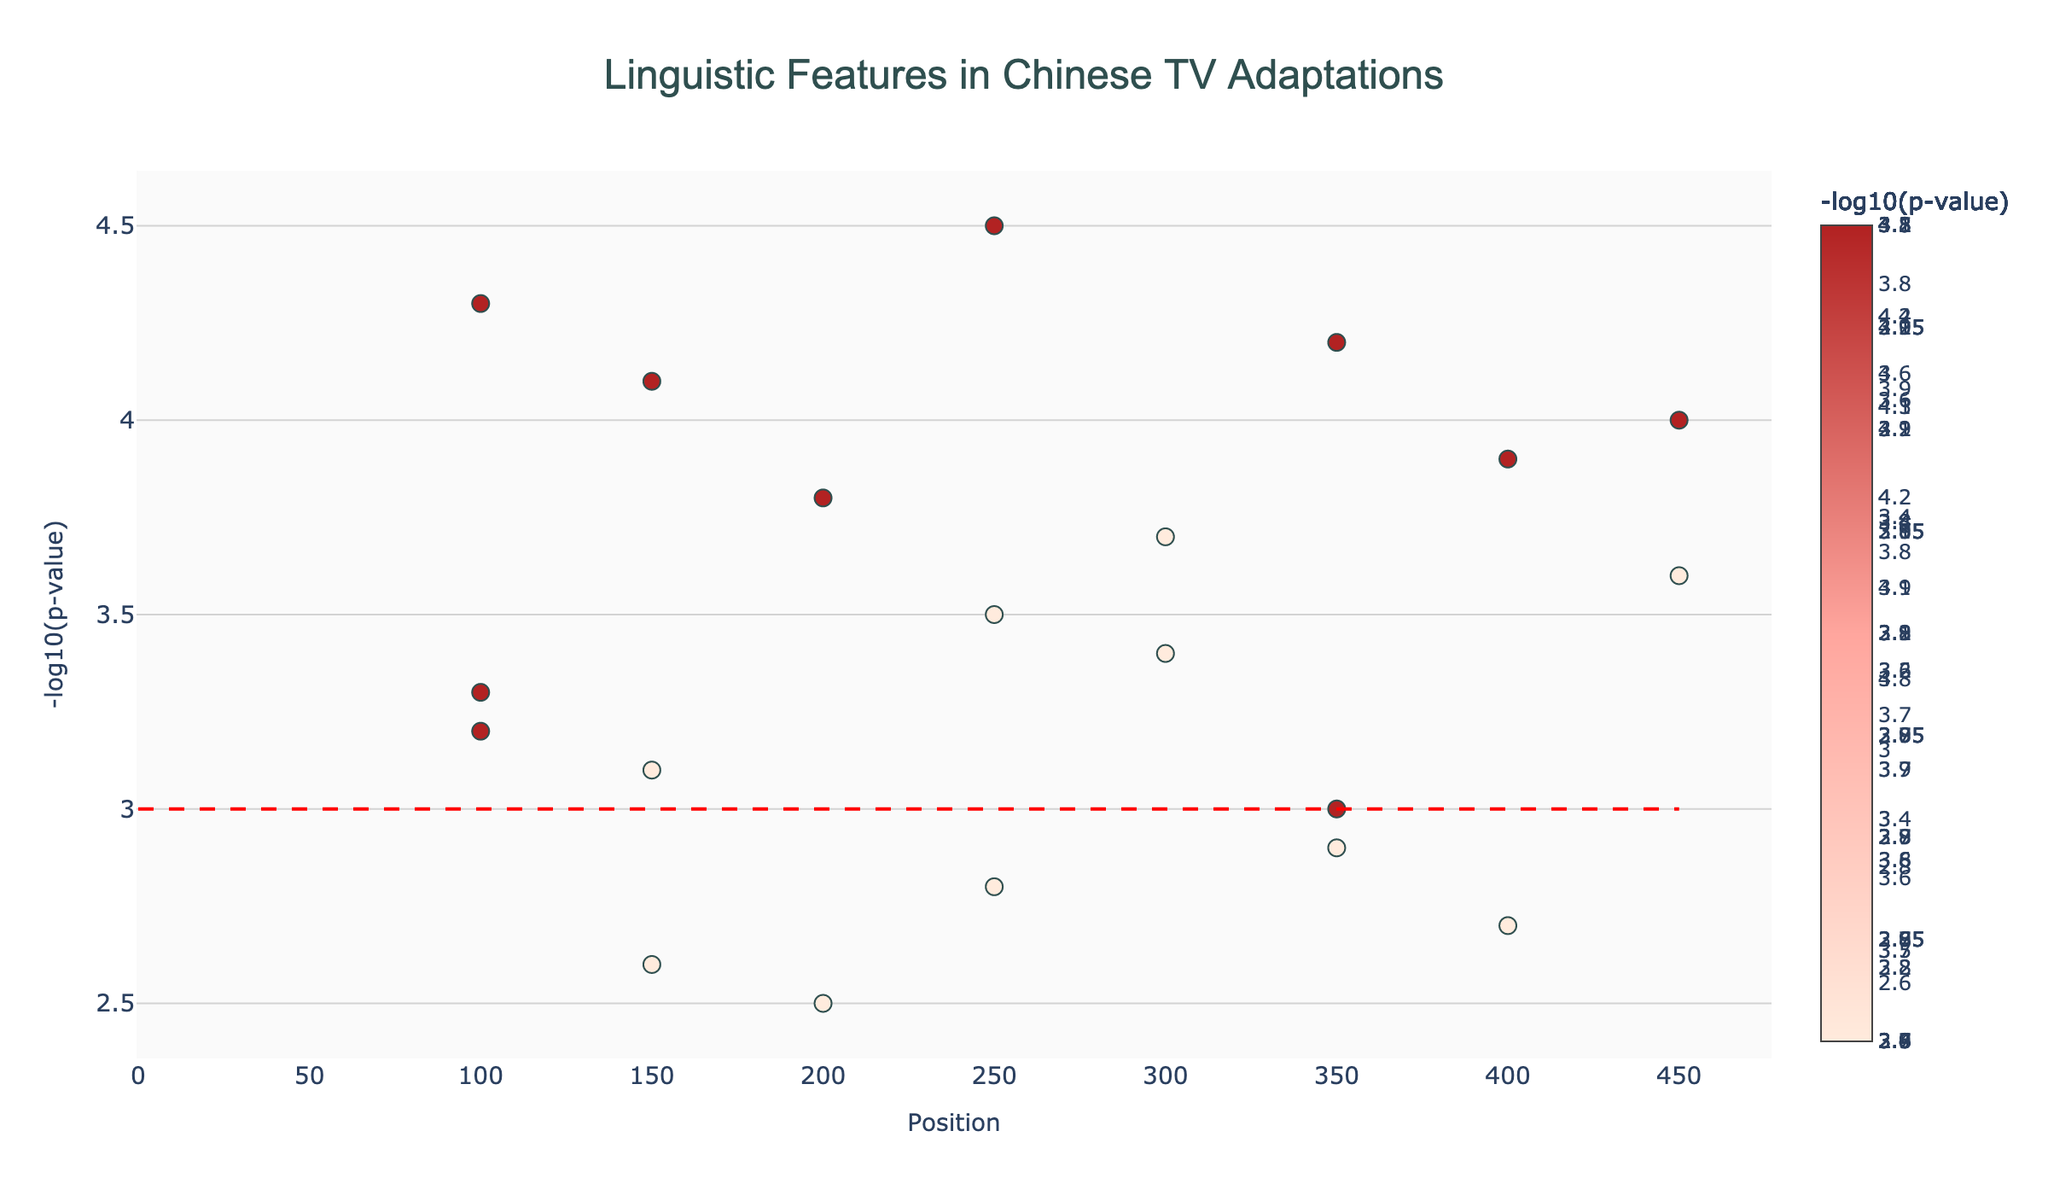What is the main title of the figure? The title of the figure is typically located at the top and summarizes the primary focus of the plot. Here, the title reads "Linguistic Features in Chinese TV Adaptations".
Answer: Linguistic Features in Chinese TV Adaptations Which feature has the highest NegativeLogPValue in the dataset? To identify the feature with the highest NegativeLogPValue, locate the highest point on the y-axis and check the feature name associated with this data point on the hover text display. Here, it is "Four-character_idioms" with a value of 4.5 on Chromosome 5 at position 250.
Answer: Four-character_idioms How many features show a significance higher than the threshold (y=3)? The significance threshold is marked by a horizontal line at y=3. Count all data points above this line by examining the figure. Here, there are 12 features exceeding this threshold.
Answer: 12 Which chromosomes have features exceeding the significance threshold of y=3? Examine the data points above the y=3 threshold line and identify their corresponding chromosomes by the x-axis position and the hover text information. Chromosomes 2, 3, 4, 5, 6, 7, 8, and 9 have such features.
Answer: 2, 3, 4, 5, 6, 7, 8, 9 Which feature on Chromosome 2 has the highest NegativeLogPValue, and what is its value? On Chromosome 2, the feature with the highest NegativeLogPValue can be identified by looking for the tallest point on the plot corresponding to Chromosome 2. The feature is "Classical_allusions" with a value of 4.1.
Answer: Classical_allusions, 4.1 What is the total number of unique features represented in the plot? Each data point represents a different feature, and we can count the unique feature names. There are 18 unique features in total.
Answer: 18 How does the NegativeLogPValue of Symbolism compare to that of Allegory? Locate the data points for Symbolism and Allegory by their hover text and compare their y-values. Symbolism has a NegativeLogPValue of 3.8 while Allegory has 2.7. Thus, Symbolism is higher.
Answer: Symbolism > Allegory What type of feature appears at position 100 on Chromosome 1 and Chromosome 8? By examining the plot, locate the data point at position 100 on Chromosome 1 and Chromosome 8 and refer to the hover text. The feature at position 100 on Chromosome 1 is "Chengyu_usage" and on Chromosome 8 is "Classical_Chinese_grammar".
Answer: Chengyu_usage, Classical_Chinese_grammar 